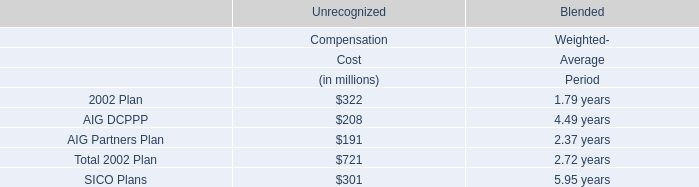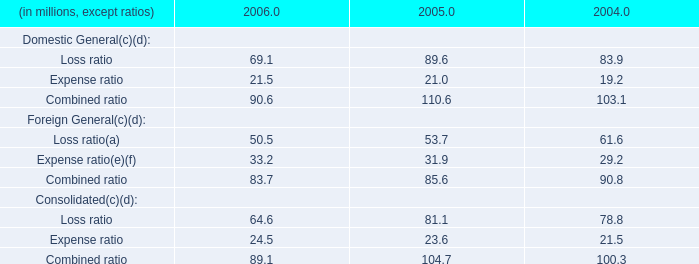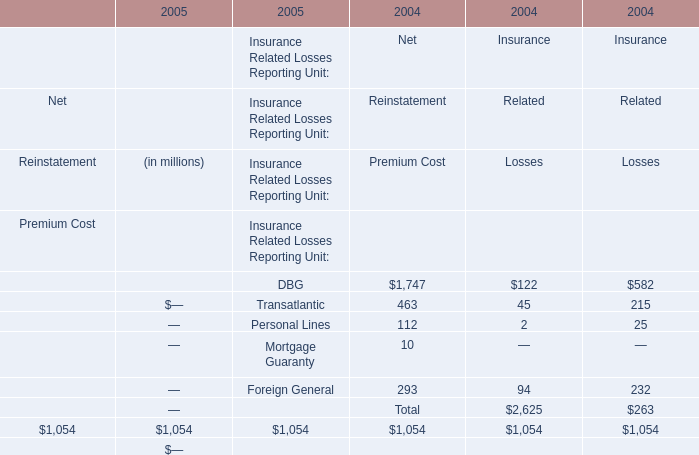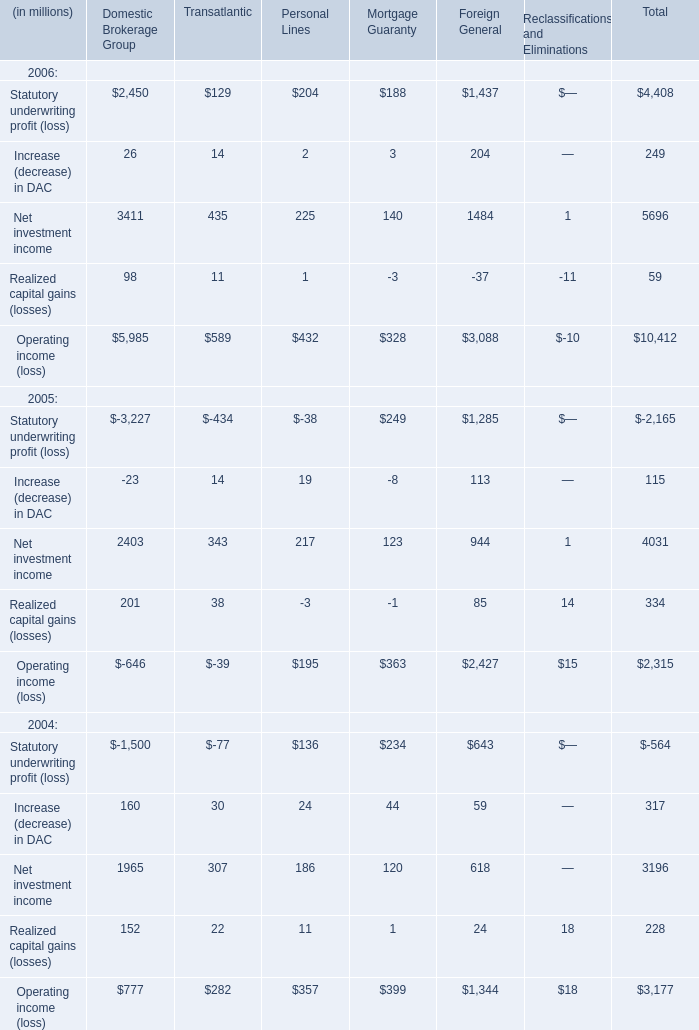What's the total amount of Transatlantic,Personal Lines,Mortgage Guaranty and Foreign General in 2006? (in million) 
Computations: (((129 + 204) + 188) + 1437)
Answer: 1958.0. 